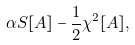<formula> <loc_0><loc_0><loc_500><loc_500>\alpha S [ A ] - \frac { 1 } { 2 } \chi ^ { 2 } [ A ] ,</formula> 